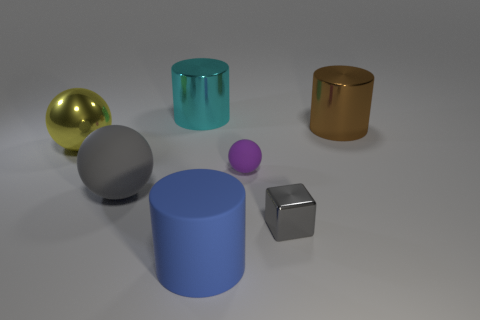Add 1 large yellow metallic things. How many objects exist? 8 Subtract all blocks. How many objects are left? 6 Add 6 large blue cylinders. How many large blue cylinders exist? 7 Subtract 0 blue spheres. How many objects are left? 7 Subtract all gray metal cubes. Subtract all blue matte cylinders. How many objects are left? 5 Add 3 large yellow metallic balls. How many large yellow metallic balls are left? 4 